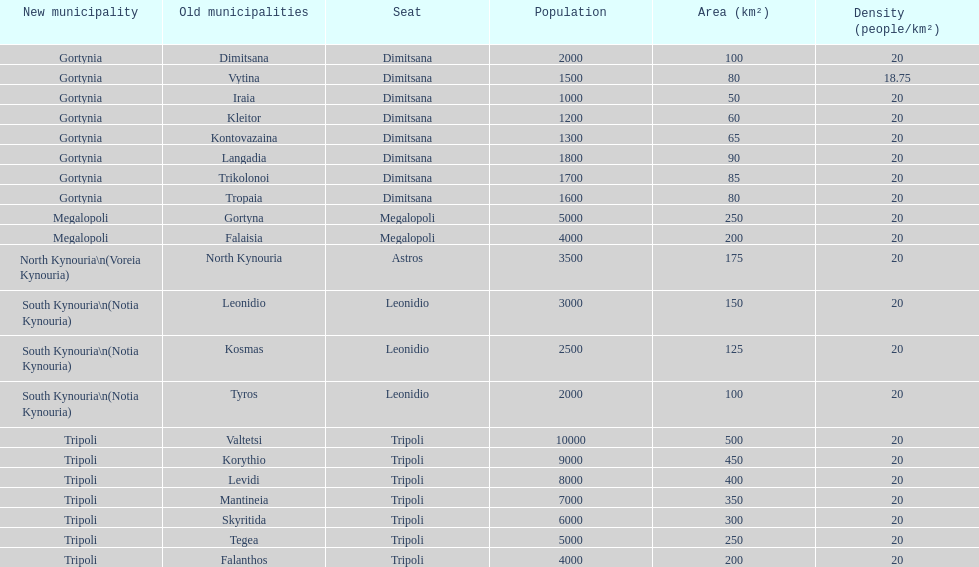What does the new municipal region of tyros consist of? South Kynouria. 